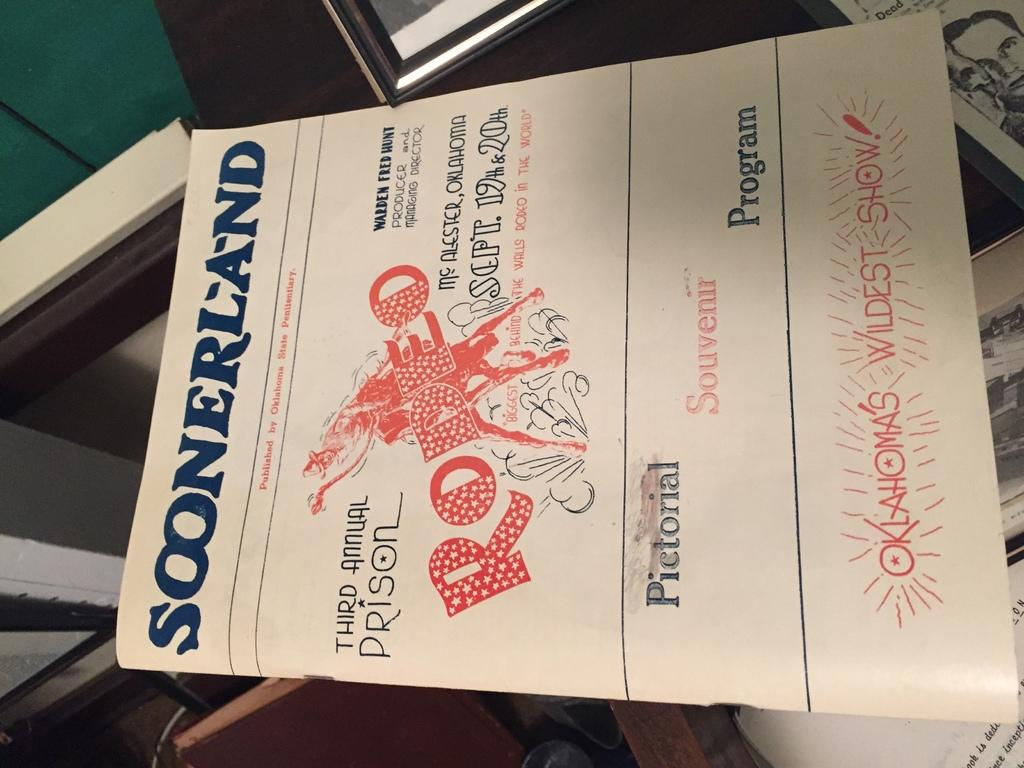<image>
Give a short and clear explanation of the subsequent image. A flyer for a rodeo called Soonerland is advertised. 